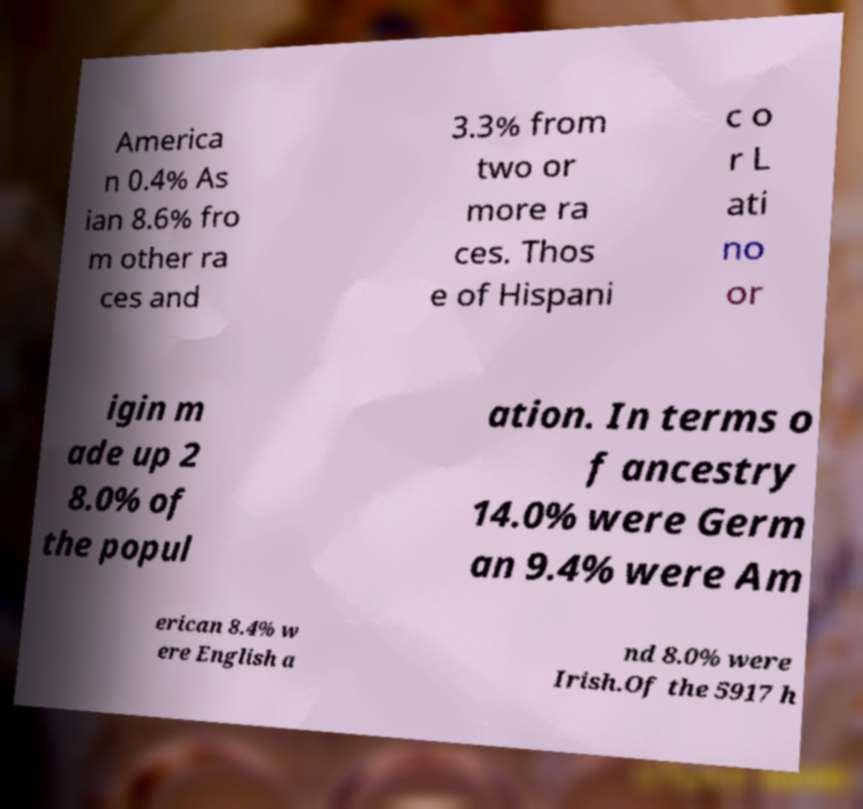Can you accurately transcribe the text from the provided image for me? America n 0.4% As ian 8.6% fro m other ra ces and 3.3% from two or more ra ces. Thos e of Hispani c o r L ati no or igin m ade up 2 8.0% of the popul ation. In terms o f ancestry 14.0% were Germ an 9.4% were Am erican 8.4% w ere English a nd 8.0% were Irish.Of the 5917 h 